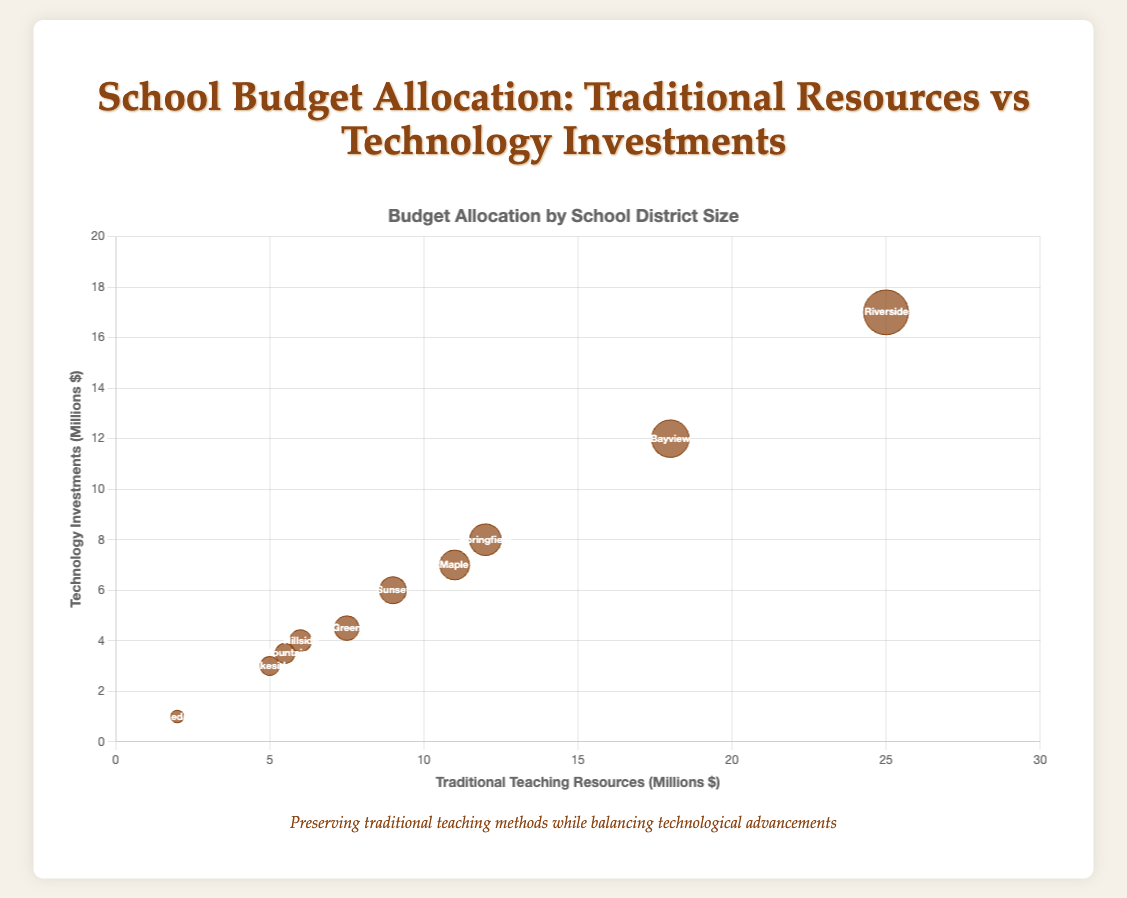What is the bubble size representing the district with the smallest size? The smallest district size is 4,000 (Cedar Park Independent School District). The bubble size is proportional to the square root of the district size divided by 100. √(4000/100) = √40 ≈ 6.32
Answer: About 6.32 Which school district allocates the highest budget to traditional teaching resources? Checking all traditional teaching resources values, Riverside Public Schools allocates $25,000,000, the highest amount in traditional teaching resources.
Answer: Riverside Public Schools What is the x-axis representing in this bubble chart? The x-axis represents the amount spent on traditional teaching resources in millions of dollars.
Answer: Traditional Teaching Resources (Millions $) How many school districts have a total budget above $30 million? By examining the data, Riverside Public Schools has a total budget of $42,000,000, and Bayview School District has $30,000,000, making two school districts above $30 million.
Answer: 2 Which school district has the smallest allocation for technology investments? Referring to the figure, Cedar Park Independent School District has the smallest technology investments of $1,000,000.
Answer: Cedar Park Independent School District Between Springfield Public Schools and Lakeside School District, which one has a larger district size? Springfield Public Schools has a district size of 25,000, while Lakeside School District has 9,000. 25,000 is greater than 9,000.
Answer: Springfield Public Schools What is the total combined allocation to traditional teaching resources across all districts? Summing up all traditional teaching resources: 12,000,000 + 5,000,000 + 7,500,000 + 6,000,000 + 9,000,000 + 18,000,000 + 11,000,000 + 2,000,000 + 25,000,000 + 5,500,000 = 101,000,000
Answer: $101,000,000 Which district has the highest technology investment and what is the value? Checking technology investments, Riverside Public Schools invests the highest with $17,000,000.
Answer: Riverside Public Schools, $17,000,000 Do any school districts spend equally on traditional teaching resources and technology investments? Comparing the data, no school district spends equally on traditional teaching resources and technology investments.
Answer: None 